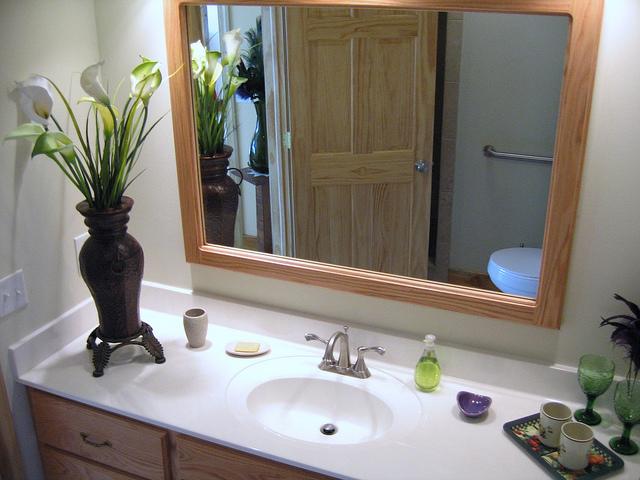Is there a vase in the bathroom?
Keep it brief. Yes. What color is the soap in the bottle?
Keep it brief. Green. Is there anyone in the bathroom?
Keep it brief. No. Is there a razor in this picture?
Write a very short answer. No. What color is the door?
Give a very brief answer. Brown. 